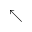Convert formula to latex. <formula><loc_0><loc_0><loc_500><loc_500>\nwarrow</formula> 